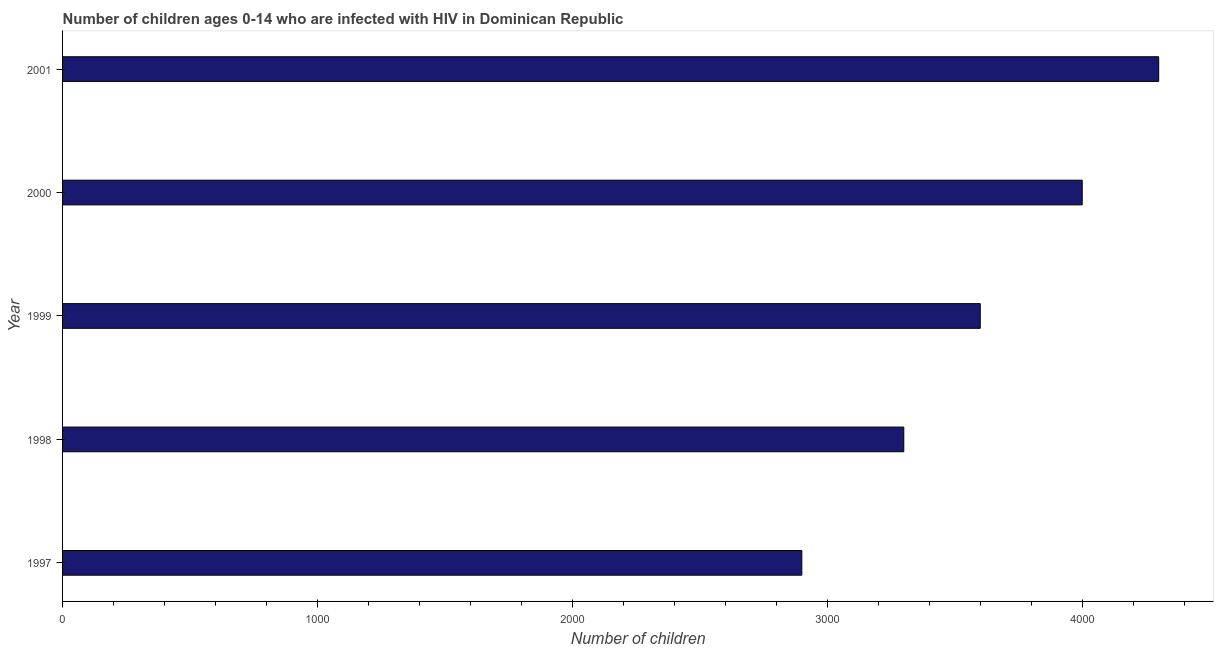Does the graph contain any zero values?
Offer a terse response. No. Does the graph contain grids?
Offer a terse response. No. What is the title of the graph?
Keep it short and to the point. Number of children ages 0-14 who are infected with HIV in Dominican Republic. What is the label or title of the X-axis?
Give a very brief answer. Number of children. What is the number of children living with hiv in 1998?
Your answer should be very brief. 3300. Across all years, what is the maximum number of children living with hiv?
Provide a short and direct response. 4300. Across all years, what is the minimum number of children living with hiv?
Ensure brevity in your answer.  2900. In which year was the number of children living with hiv maximum?
Ensure brevity in your answer.  2001. What is the sum of the number of children living with hiv?
Offer a very short reply. 1.81e+04. What is the difference between the number of children living with hiv in 1997 and 1999?
Give a very brief answer. -700. What is the average number of children living with hiv per year?
Give a very brief answer. 3620. What is the median number of children living with hiv?
Keep it short and to the point. 3600. What is the ratio of the number of children living with hiv in 1997 to that in 2001?
Make the answer very short. 0.67. Is the number of children living with hiv in 1998 less than that in 2001?
Offer a terse response. Yes. Is the difference between the number of children living with hiv in 1997 and 1998 greater than the difference between any two years?
Give a very brief answer. No. What is the difference between the highest and the second highest number of children living with hiv?
Your answer should be very brief. 300. Is the sum of the number of children living with hiv in 1997 and 1999 greater than the maximum number of children living with hiv across all years?
Ensure brevity in your answer.  Yes. What is the difference between the highest and the lowest number of children living with hiv?
Give a very brief answer. 1400. In how many years, is the number of children living with hiv greater than the average number of children living with hiv taken over all years?
Provide a short and direct response. 2. How many bars are there?
Provide a short and direct response. 5. Are all the bars in the graph horizontal?
Provide a succinct answer. Yes. What is the difference between two consecutive major ticks on the X-axis?
Your answer should be compact. 1000. What is the Number of children of 1997?
Provide a short and direct response. 2900. What is the Number of children in 1998?
Keep it short and to the point. 3300. What is the Number of children in 1999?
Give a very brief answer. 3600. What is the Number of children of 2000?
Your answer should be very brief. 4000. What is the Number of children of 2001?
Your response must be concise. 4300. What is the difference between the Number of children in 1997 and 1998?
Offer a very short reply. -400. What is the difference between the Number of children in 1997 and 1999?
Your response must be concise. -700. What is the difference between the Number of children in 1997 and 2000?
Make the answer very short. -1100. What is the difference between the Number of children in 1997 and 2001?
Keep it short and to the point. -1400. What is the difference between the Number of children in 1998 and 1999?
Provide a succinct answer. -300. What is the difference between the Number of children in 1998 and 2000?
Make the answer very short. -700. What is the difference between the Number of children in 1998 and 2001?
Ensure brevity in your answer.  -1000. What is the difference between the Number of children in 1999 and 2000?
Ensure brevity in your answer.  -400. What is the difference between the Number of children in 1999 and 2001?
Your response must be concise. -700. What is the difference between the Number of children in 2000 and 2001?
Offer a terse response. -300. What is the ratio of the Number of children in 1997 to that in 1998?
Offer a terse response. 0.88. What is the ratio of the Number of children in 1997 to that in 1999?
Offer a terse response. 0.81. What is the ratio of the Number of children in 1997 to that in 2000?
Ensure brevity in your answer.  0.72. What is the ratio of the Number of children in 1997 to that in 2001?
Your answer should be very brief. 0.67. What is the ratio of the Number of children in 1998 to that in 1999?
Your response must be concise. 0.92. What is the ratio of the Number of children in 1998 to that in 2000?
Provide a succinct answer. 0.82. What is the ratio of the Number of children in 1998 to that in 2001?
Ensure brevity in your answer.  0.77. What is the ratio of the Number of children in 1999 to that in 2001?
Give a very brief answer. 0.84. 